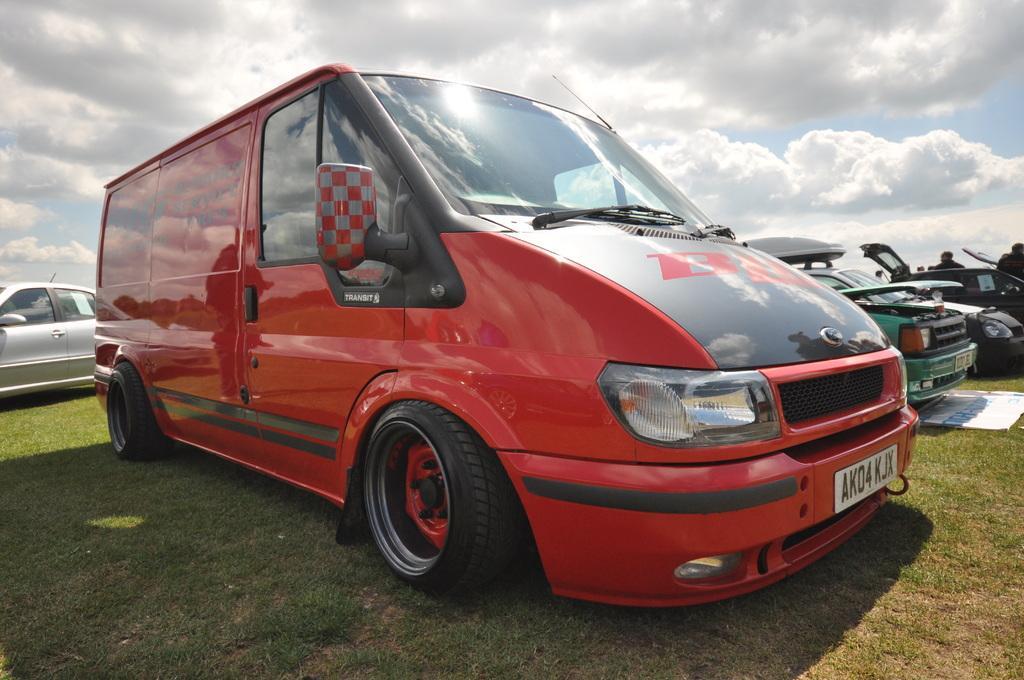Could you give a brief overview of what you see in this image? In this image I can see few vehicles on the ground. There is some grass on the ground. At the top I can see clouds in the sky. 